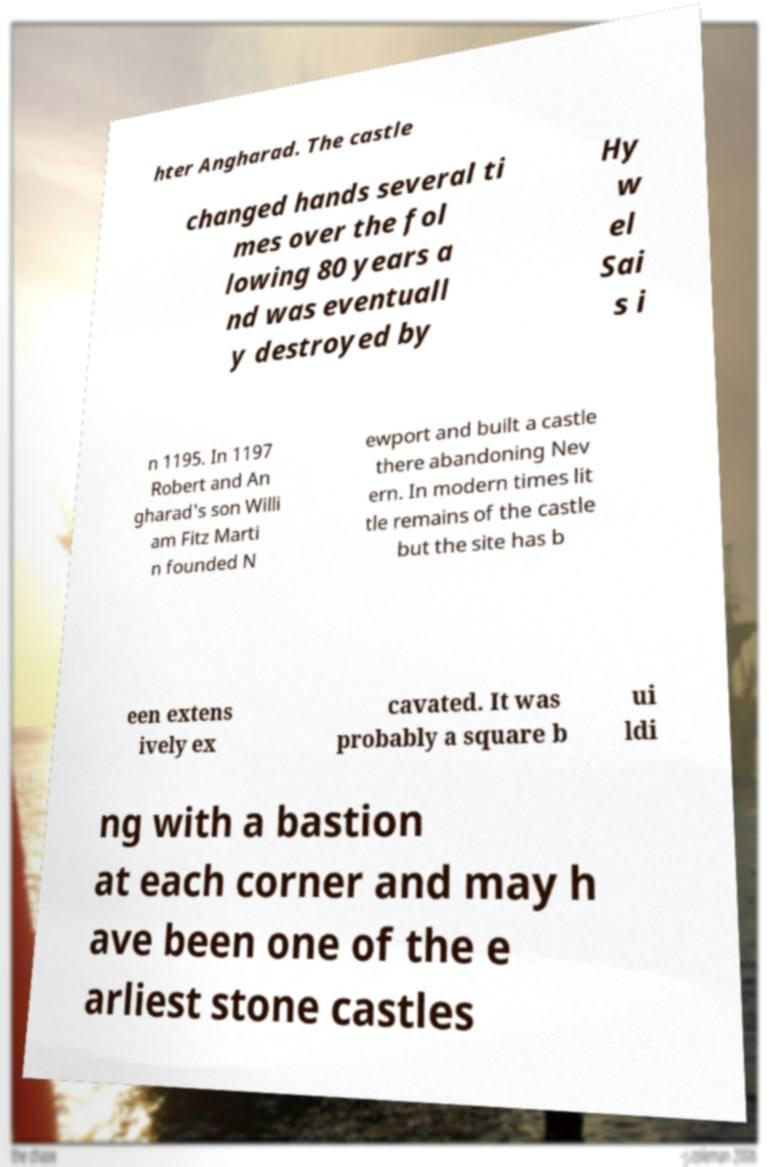For documentation purposes, I need the text within this image transcribed. Could you provide that? hter Angharad. The castle changed hands several ti mes over the fol lowing 80 years a nd was eventuall y destroyed by Hy w el Sai s i n 1195. In 1197 Robert and An gharad's son Willi am Fitz Marti n founded N ewport and built a castle there abandoning Nev ern. In modern times lit tle remains of the castle but the site has b een extens ively ex cavated. It was probably a square b ui ldi ng with a bastion at each corner and may h ave been one of the e arliest stone castles 